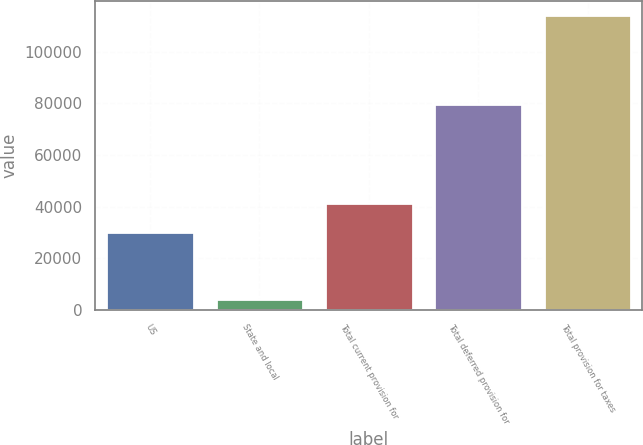Convert chart. <chart><loc_0><loc_0><loc_500><loc_500><bar_chart><fcel>US<fcel>State and local<fcel>Total current provision for<fcel>Total deferred provision for<fcel>Total provision for taxes<nl><fcel>30273<fcel>4074<fcel>41284.6<fcel>79843<fcel>114190<nl></chart> 